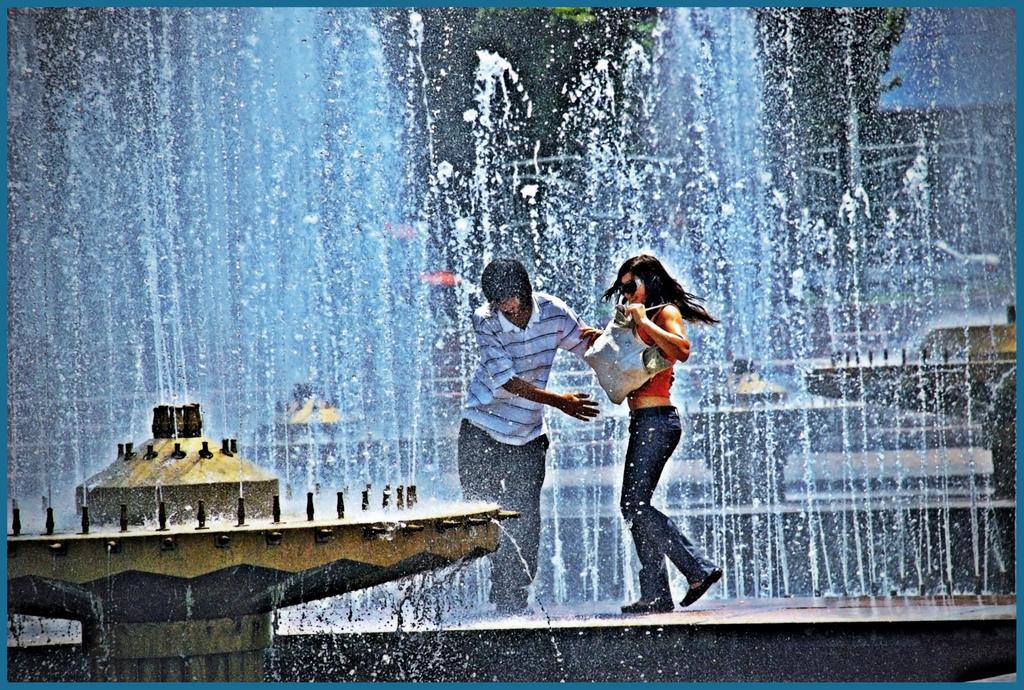In one or two sentences, can you explain what this image depicts? In this image I can see an artificial fountain in the left bottom corner. I can see other fountains behind. I can see two people standing on the wall of the fountain one man and a woman. The woman is wearing a bag, the man is trying to hold her. 